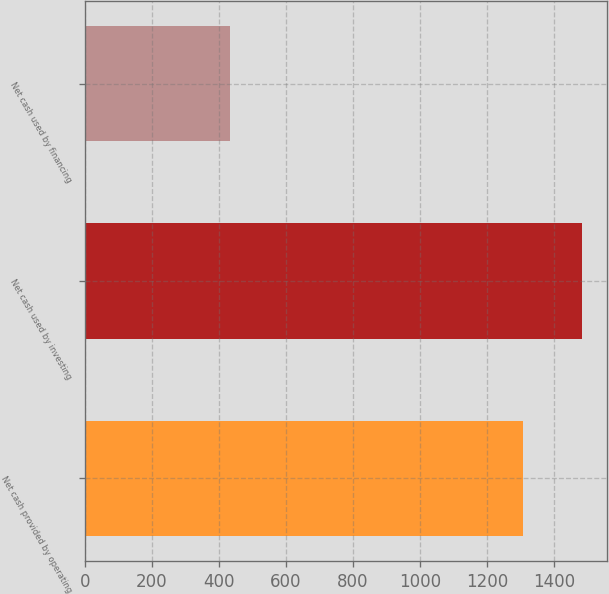Convert chart. <chart><loc_0><loc_0><loc_500><loc_500><bar_chart><fcel>Net cash provided by operating<fcel>Net cash used by investing<fcel>Net cash used by financing<nl><fcel>1309<fcel>1485<fcel>432<nl></chart> 